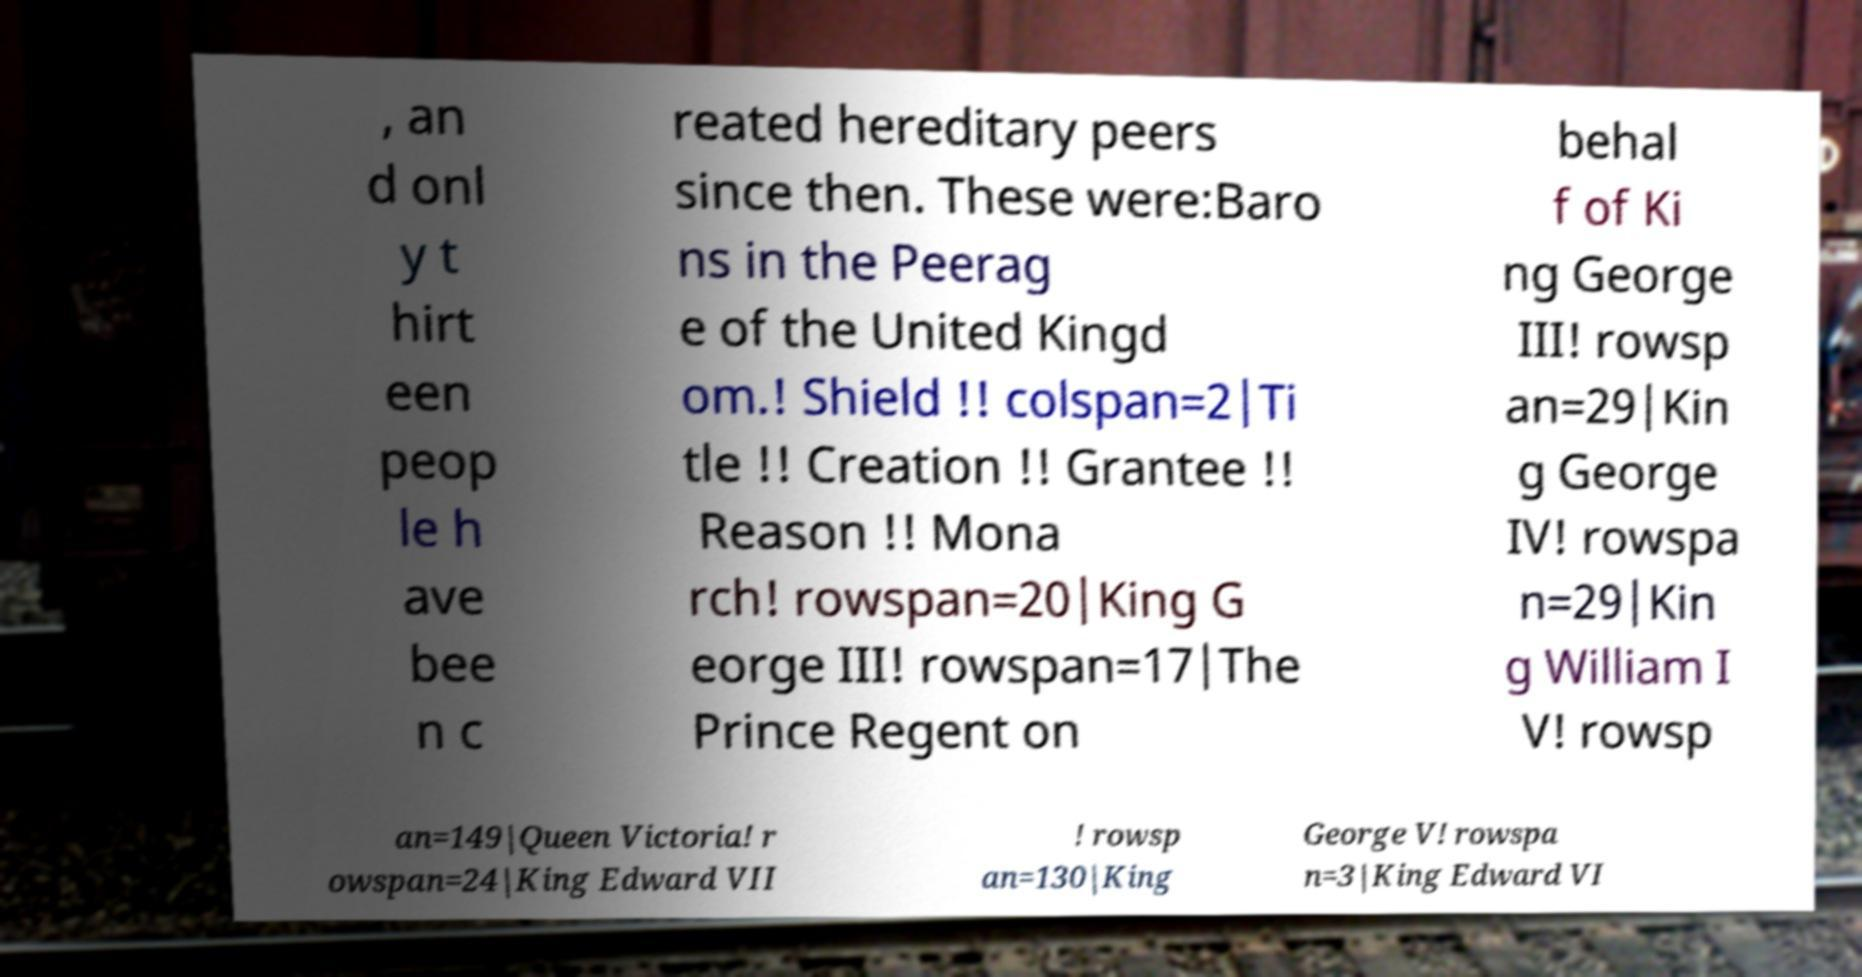Could you extract and type out the text from this image? , an d onl y t hirt een peop le h ave bee n c reated hereditary peers since then. These were:Baro ns in the Peerag e of the United Kingd om.! Shield !! colspan=2|Ti tle !! Creation !! Grantee !! Reason !! Mona rch! rowspan=20|King G eorge III! rowspan=17|The Prince Regent on behal f of Ki ng George III! rowsp an=29|Kin g George IV! rowspa n=29|Kin g William I V! rowsp an=149|Queen Victoria! r owspan=24|King Edward VII ! rowsp an=130|King George V! rowspa n=3|King Edward VI 